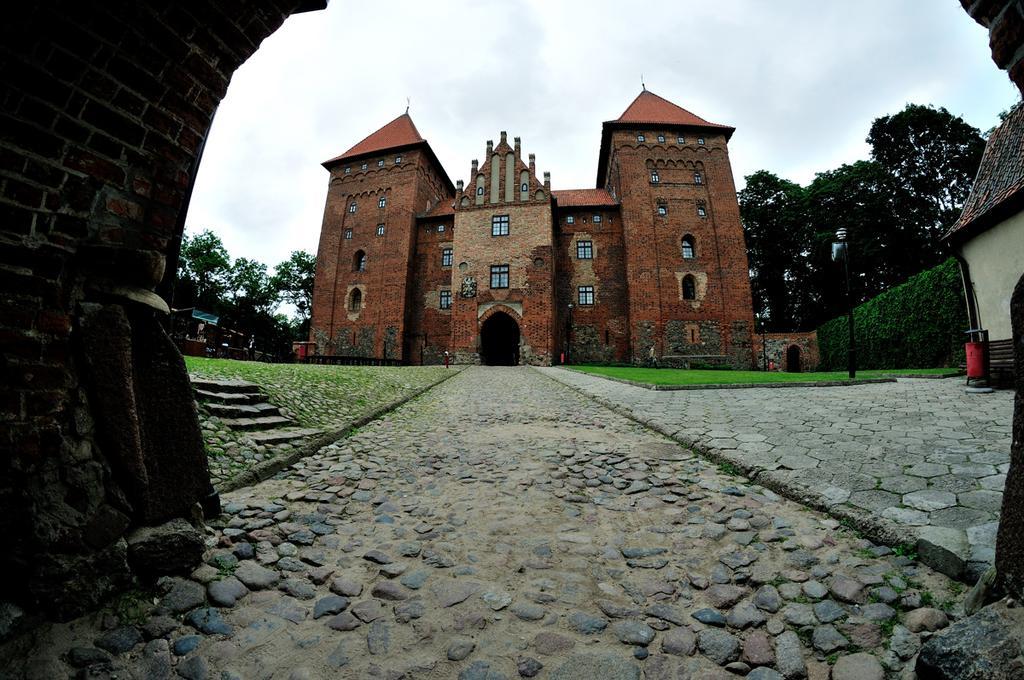Can you describe this image briefly? As we can see in the image there are buildings, grass and trees. On the top there is sky. 